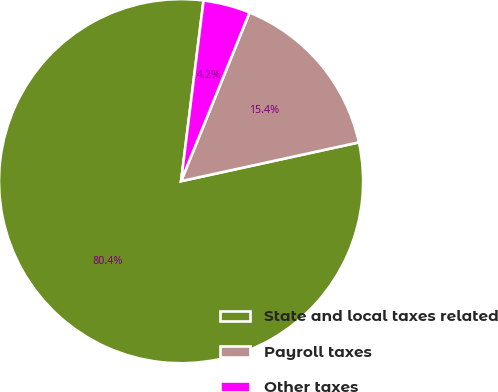<chart> <loc_0><loc_0><loc_500><loc_500><pie_chart><fcel>State and local taxes related<fcel>Payroll taxes<fcel>Other taxes<nl><fcel>80.39%<fcel>15.44%<fcel>4.17%<nl></chart> 